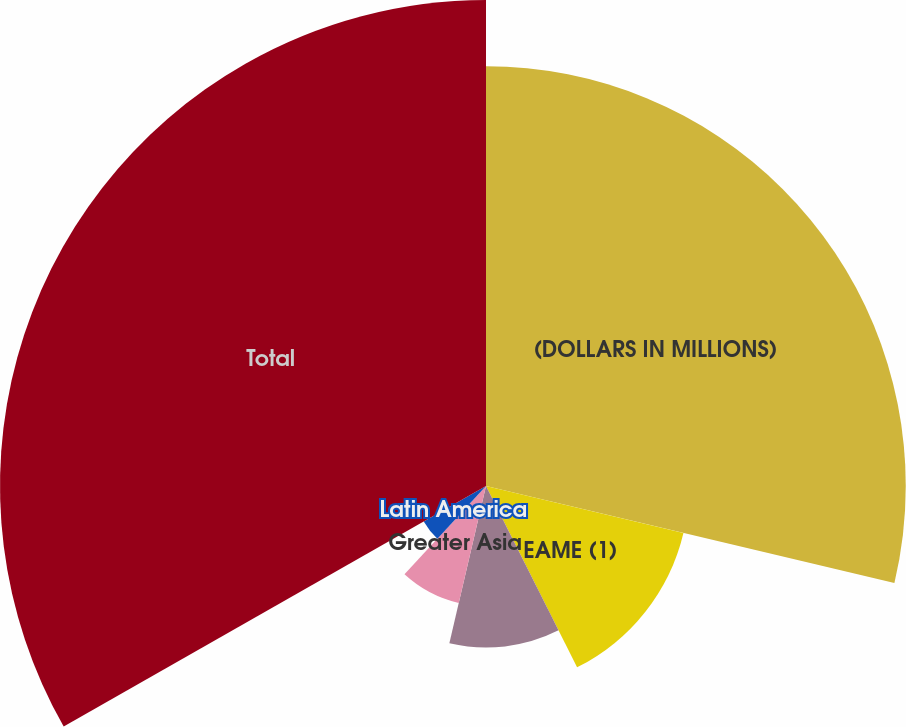<chart> <loc_0><loc_0><loc_500><loc_500><pie_chart><fcel>(DOLLARS IN MILLIONS)<fcel>EAME (1)<fcel>North America<fcel>Greater Asia<fcel>Latin America<fcel>Total<nl><fcel>28.71%<fcel>13.88%<fcel>11.05%<fcel>8.22%<fcel>4.9%<fcel>33.24%<nl></chart> 